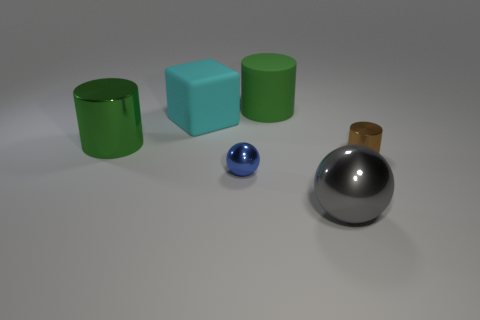Subtract all tiny shiny cylinders. How many cylinders are left? 2 Subtract 1 cylinders. How many cylinders are left? 2 Subtract all blue balls. How many balls are left? 1 Add 1 green metallic cylinders. How many objects exist? 7 Subtract all balls. How many objects are left? 4 Subtract all cyan cylinders. Subtract all yellow cubes. How many cylinders are left? 3 Subtract all yellow cylinders. How many yellow balls are left? 0 Subtract all small green rubber cylinders. Subtract all tiny spheres. How many objects are left? 5 Add 4 big green metallic objects. How many big green metallic objects are left? 5 Add 5 matte cubes. How many matte cubes exist? 6 